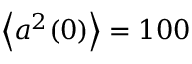Convert formula to latex. <formula><loc_0><loc_0><loc_500><loc_500>\left \langle a ^ { 2 } ( 0 ) \right \rangle = 1 0 0</formula> 